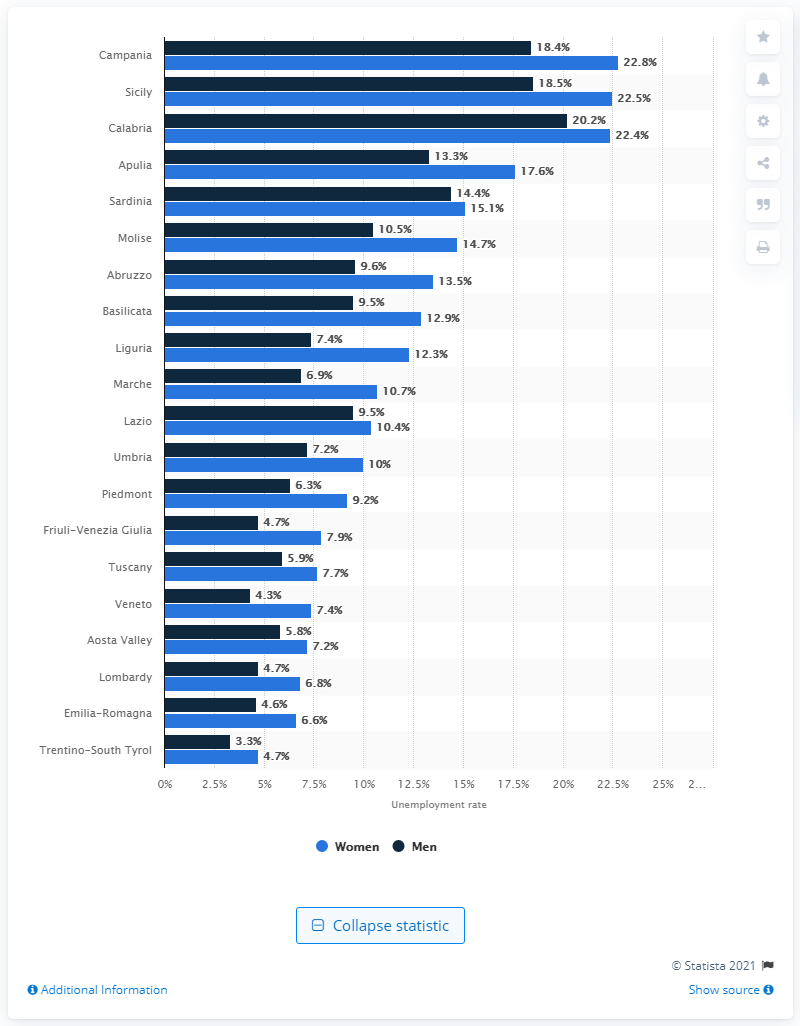List a handful of essential elements in this visual. In 2019, 3.3% of the male workforce in Trentino-South Tyrol did not have a job. In 2019, the Italian region with the lowest unemployment rate was Trentino-South Tyrol. 